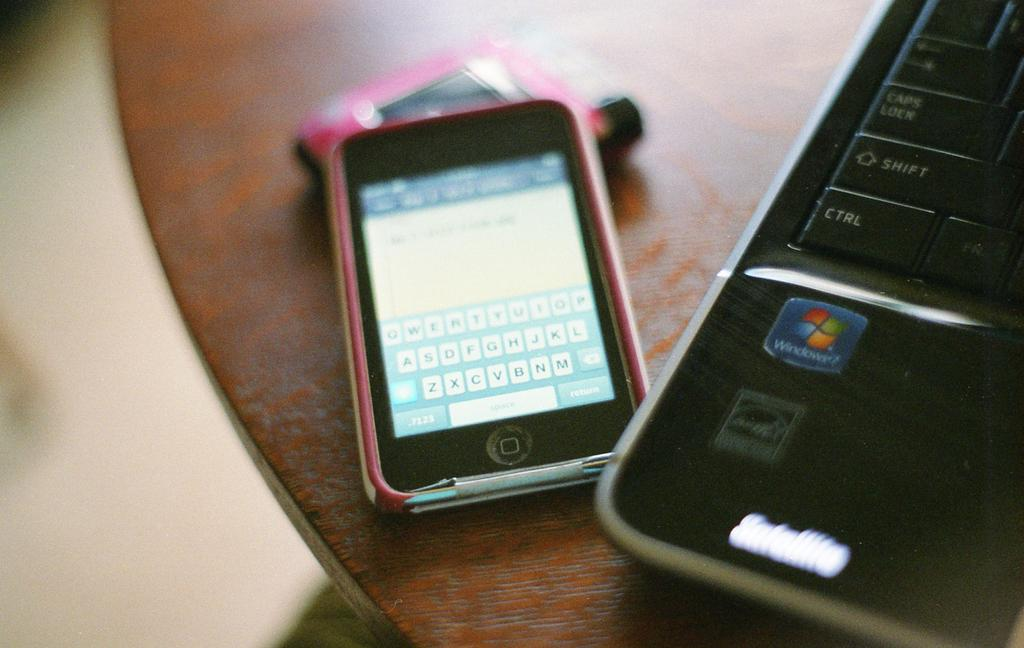<image>
Give a short and clear explanation of the subsequent image. An Iphone and a parcel picture of a laptop that runs Windows 7. 